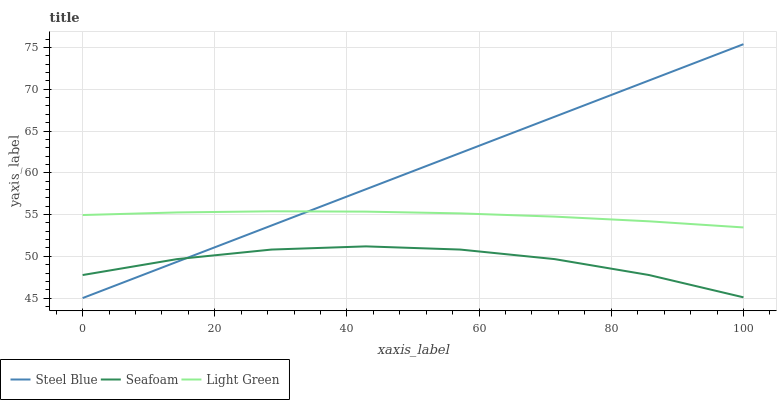Does Seafoam have the minimum area under the curve?
Answer yes or no. Yes. Does Steel Blue have the maximum area under the curve?
Answer yes or no. Yes. Does Light Green have the minimum area under the curve?
Answer yes or no. No. Does Light Green have the maximum area under the curve?
Answer yes or no. No. Is Steel Blue the smoothest?
Answer yes or no. Yes. Is Seafoam the roughest?
Answer yes or no. Yes. Is Light Green the smoothest?
Answer yes or no. No. Is Light Green the roughest?
Answer yes or no. No. Does Steel Blue have the lowest value?
Answer yes or no. Yes. Does Seafoam have the lowest value?
Answer yes or no. No. Does Steel Blue have the highest value?
Answer yes or no. Yes. Does Light Green have the highest value?
Answer yes or no. No. Is Seafoam less than Light Green?
Answer yes or no. Yes. Is Light Green greater than Seafoam?
Answer yes or no. Yes. Does Seafoam intersect Steel Blue?
Answer yes or no. Yes. Is Seafoam less than Steel Blue?
Answer yes or no. No. Is Seafoam greater than Steel Blue?
Answer yes or no. No. Does Seafoam intersect Light Green?
Answer yes or no. No. 